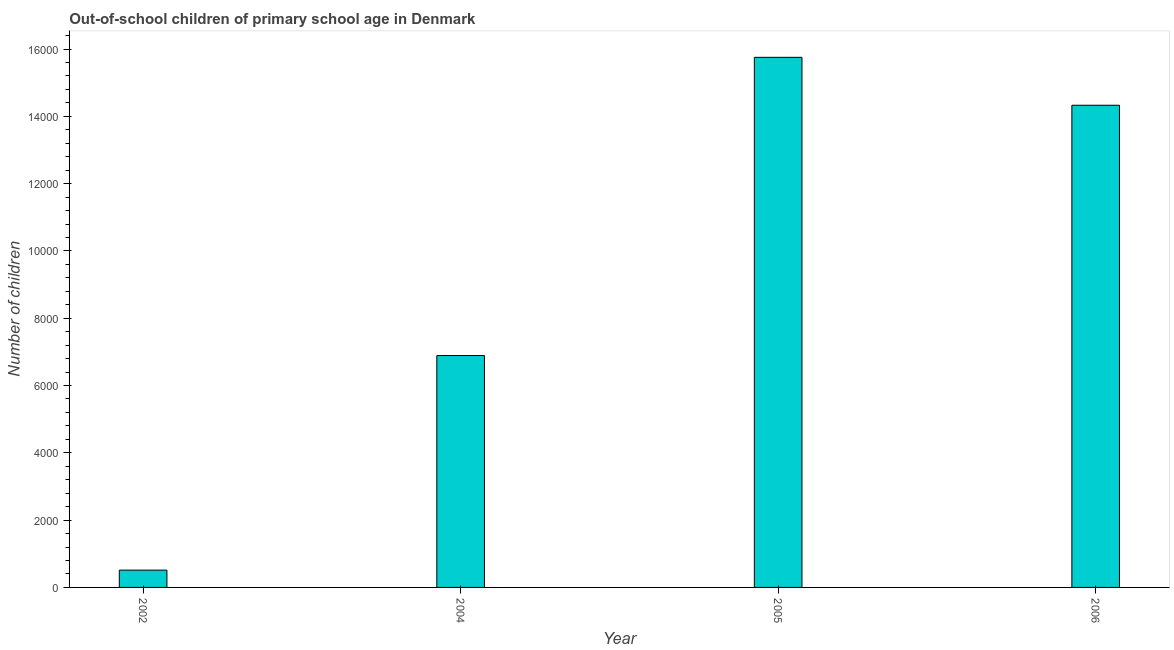What is the title of the graph?
Ensure brevity in your answer.  Out-of-school children of primary school age in Denmark. What is the label or title of the Y-axis?
Offer a very short reply. Number of children. What is the number of out-of-school children in 2005?
Keep it short and to the point. 1.58e+04. Across all years, what is the maximum number of out-of-school children?
Keep it short and to the point. 1.58e+04. Across all years, what is the minimum number of out-of-school children?
Your answer should be compact. 514. In which year was the number of out-of-school children maximum?
Offer a terse response. 2005. In which year was the number of out-of-school children minimum?
Provide a succinct answer. 2002. What is the sum of the number of out-of-school children?
Your answer should be compact. 3.75e+04. What is the difference between the number of out-of-school children in 2002 and 2006?
Provide a short and direct response. -1.38e+04. What is the average number of out-of-school children per year?
Your answer should be compact. 9372. What is the median number of out-of-school children?
Give a very brief answer. 1.06e+04. In how many years, is the number of out-of-school children greater than 5200 ?
Ensure brevity in your answer.  3. What is the ratio of the number of out-of-school children in 2002 to that in 2006?
Offer a terse response. 0.04. What is the difference between the highest and the second highest number of out-of-school children?
Provide a short and direct response. 1424. What is the difference between the highest and the lowest number of out-of-school children?
Your answer should be very brief. 1.52e+04. In how many years, is the number of out-of-school children greater than the average number of out-of-school children taken over all years?
Offer a terse response. 2. Are all the bars in the graph horizontal?
Your response must be concise. No. How many years are there in the graph?
Offer a very short reply. 4. Are the values on the major ticks of Y-axis written in scientific E-notation?
Make the answer very short. No. What is the Number of children in 2002?
Offer a very short reply. 514. What is the Number of children in 2004?
Provide a succinct answer. 6892. What is the Number of children of 2005?
Make the answer very short. 1.58e+04. What is the Number of children in 2006?
Ensure brevity in your answer.  1.43e+04. What is the difference between the Number of children in 2002 and 2004?
Provide a succinct answer. -6378. What is the difference between the Number of children in 2002 and 2005?
Your response must be concise. -1.52e+04. What is the difference between the Number of children in 2002 and 2006?
Make the answer very short. -1.38e+04. What is the difference between the Number of children in 2004 and 2005?
Provide a short and direct response. -8862. What is the difference between the Number of children in 2004 and 2006?
Keep it short and to the point. -7438. What is the difference between the Number of children in 2005 and 2006?
Ensure brevity in your answer.  1424. What is the ratio of the Number of children in 2002 to that in 2004?
Keep it short and to the point. 0.07. What is the ratio of the Number of children in 2002 to that in 2005?
Make the answer very short. 0.03. What is the ratio of the Number of children in 2002 to that in 2006?
Offer a terse response. 0.04. What is the ratio of the Number of children in 2004 to that in 2005?
Keep it short and to the point. 0.44. What is the ratio of the Number of children in 2004 to that in 2006?
Your answer should be very brief. 0.48. What is the ratio of the Number of children in 2005 to that in 2006?
Provide a short and direct response. 1.1. 